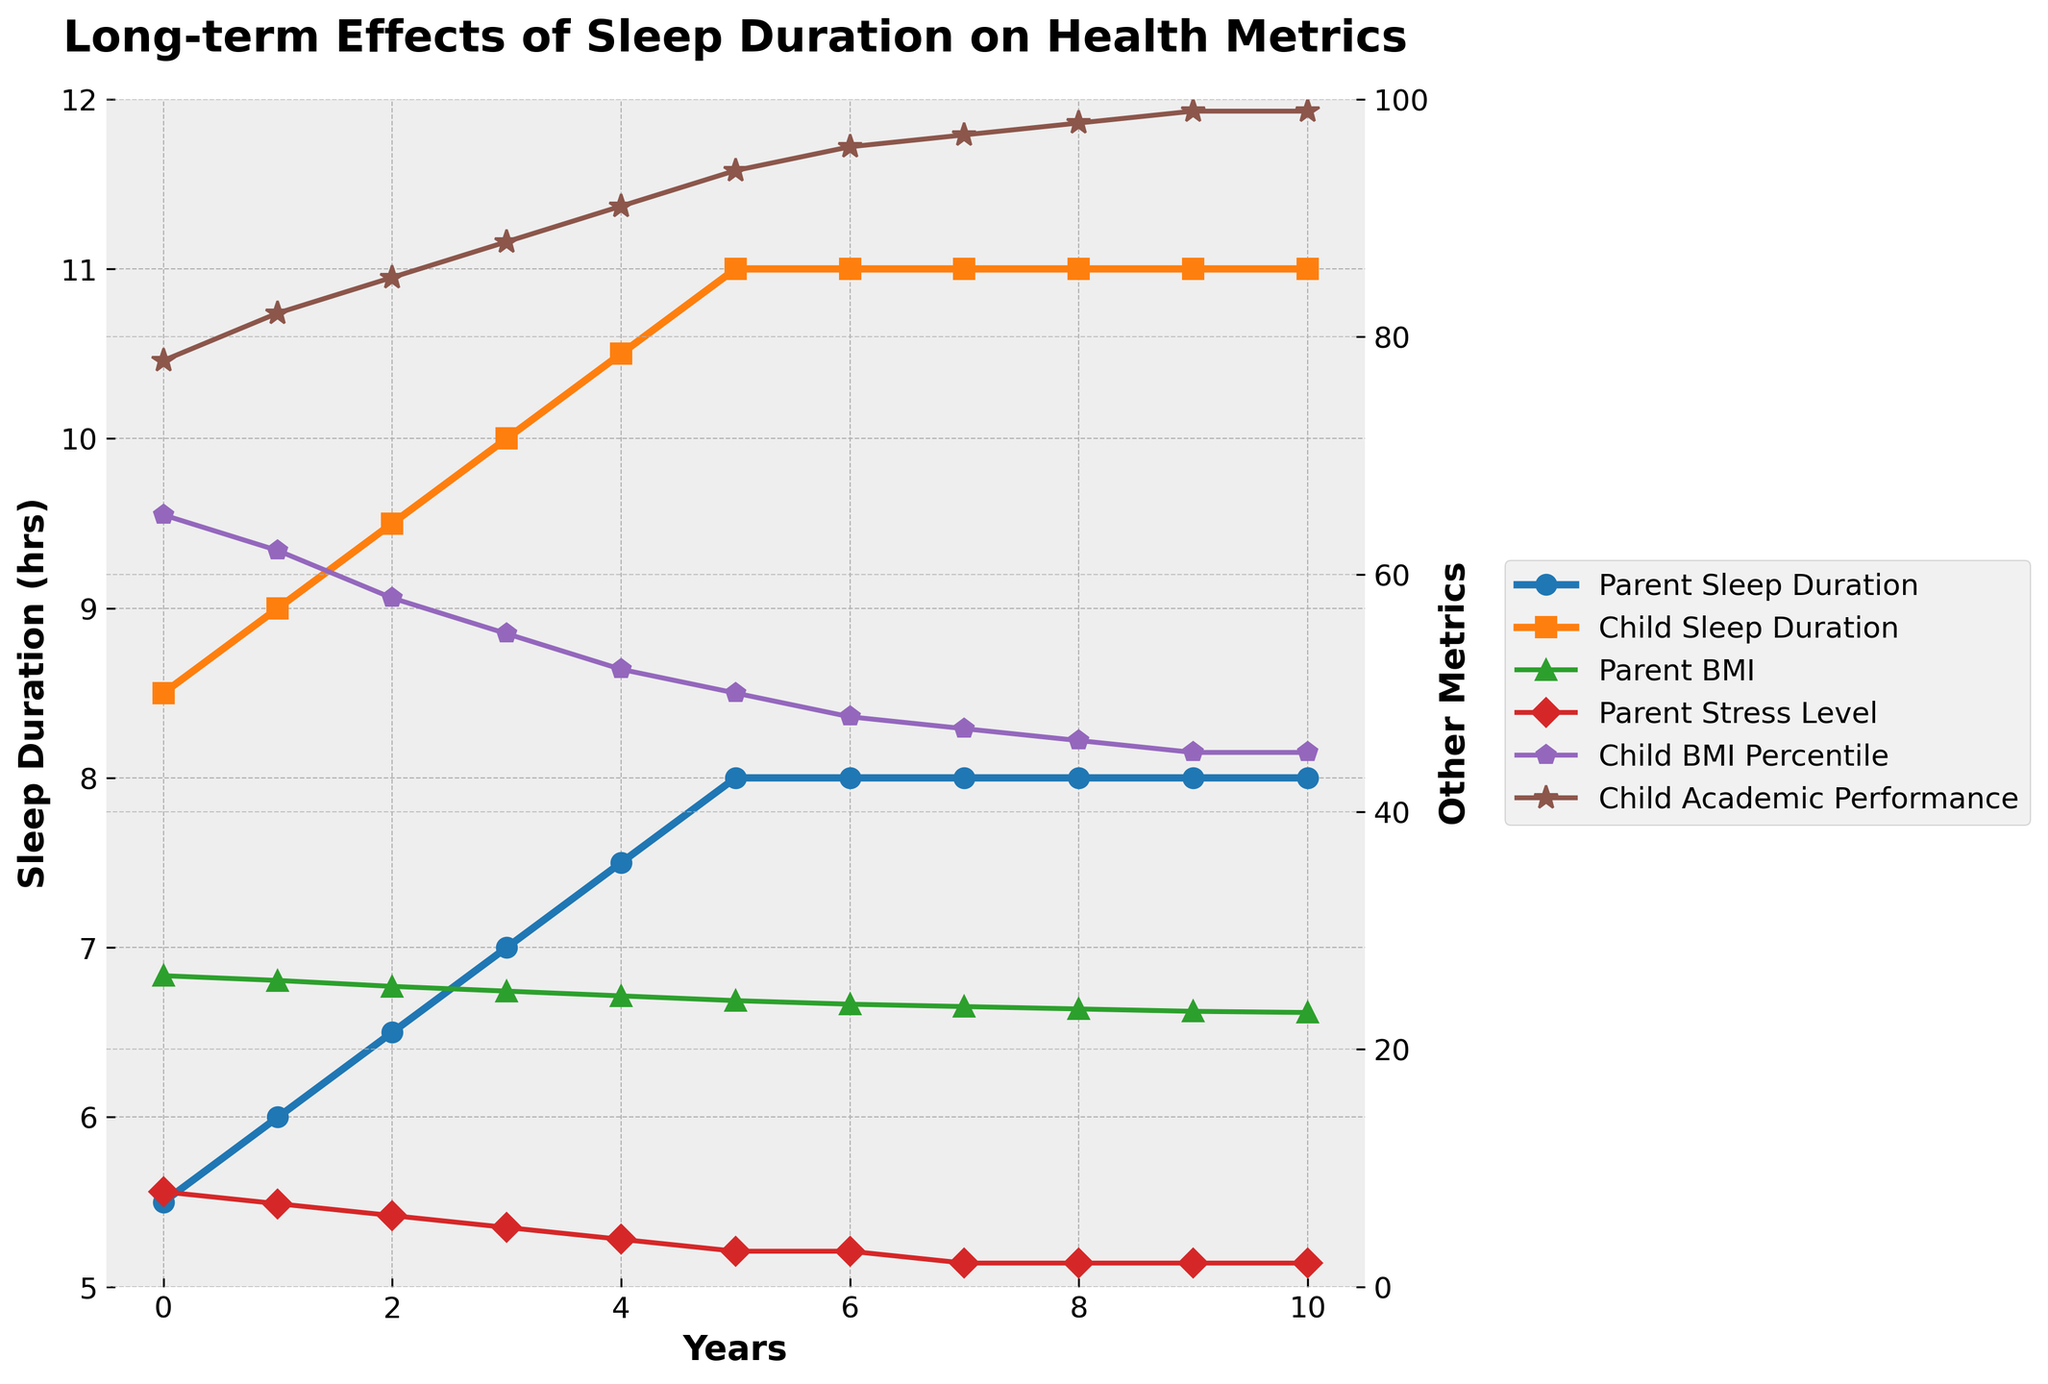Is there a trend in Parent BMI and how is it related to Parent Sleep Duration over the years? As the Parent Sleep Duration increases from 5.5 hours to 8 hours over the 10 years, the Parent BMI consistently decreases from 26.2 to 23.1. This suggests a negative correlation; as sleep duration increases, BMI decreases.
Answer: Negative correlation; as sleep increases BMI decreases Which metric shows the most significant improvement in children over the years? The Child Academic Performance shows the most significant improvement, increasing from 78 to 99 points over the 10-year period, indicating a consistent upward trend compared to other metrics.
Answer: Child Academic Performance What is the average stress level for parents over the years? To find the average, sum the stress levels: 8 + 7 + 6 + 5 + 4 + 3 + 3 + 2 + 2 + 2 = 42. Then divide by the number of years (11): 42 / 11 ≈ 3.82
Answer: ≈ 3.82 How does the Child BMI Percentile change in relation to the Child Sleep Duration? As Child Sleep Duration increases from 8.5 hours to 11 hours over 10 years, the Child BMI Percentile decreases from 65 to 45. This suggests a negative correlation where more sleep is associated with a healthier BMI percentile in children.
Answer: Negative correlation What year does the Parent and Child Sleep Duration both first reach 8 hours? From the plot, both Parent and Child Sleep Duration first reach 8 hours in year 5.
Answer: Year 5 Compare the change in Parent Stress Level and Child Academic Performance after 5 years. Parent Stress Level decreases from 8 to 3 (a 5-point drop), while Child Academic Performance increases from 78 to 94 (a 16-point rise).
Answer: Stress: -5 points, Academic Performance: +16 points How does the Parent BMI at the end of the 10 years compare to the start of the observation? The Parent BMI starts at 26.2 and ends at 23.1 after 10 years, showing a significant decrease.
Answer: Decreases Is there any period where the Parent Sleep Duration remains constant? If so, when? The Parent Sleep Duration remains constant at 8.0 hours from years 6 to 10.
Answer: Years 6 to 10 Does the Child Academic Performance ever plateau? If so, when? Yes, Child Academic Performance plateaus at 99 from year 9 to year 10.
Answer: Years 9 to 10 